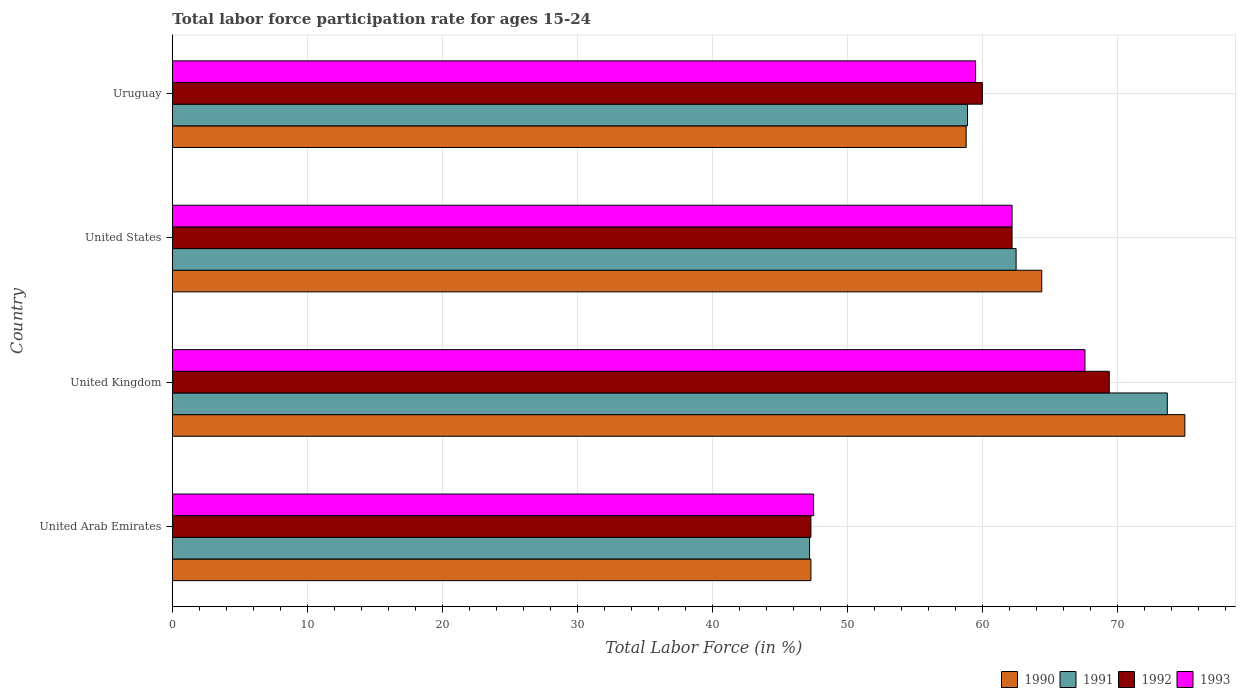How many different coloured bars are there?
Give a very brief answer. 4. Are the number of bars per tick equal to the number of legend labels?
Provide a succinct answer. Yes. Are the number of bars on each tick of the Y-axis equal?
Your answer should be very brief. Yes. How many bars are there on the 3rd tick from the bottom?
Your answer should be compact. 4. What is the label of the 1st group of bars from the top?
Offer a terse response. Uruguay. What is the labor force participation rate in 1991 in United States?
Keep it short and to the point. 62.5. Across all countries, what is the minimum labor force participation rate in 1992?
Provide a succinct answer. 47.3. In which country was the labor force participation rate in 1992 maximum?
Offer a terse response. United Kingdom. In which country was the labor force participation rate in 1992 minimum?
Offer a very short reply. United Arab Emirates. What is the total labor force participation rate in 1990 in the graph?
Your answer should be very brief. 245.5. What is the difference between the labor force participation rate in 1990 in United Arab Emirates and that in Uruguay?
Keep it short and to the point. -11.5. What is the difference between the labor force participation rate in 1990 in Uruguay and the labor force participation rate in 1991 in United Arab Emirates?
Give a very brief answer. 11.6. What is the average labor force participation rate in 1990 per country?
Provide a short and direct response. 61.37. What is the difference between the labor force participation rate in 1992 and labor force participation rate in 1991 in United States?
Your answer should be very brief. -0.3. In how many countries, is the labor force participation rate in 1992 greater than 40 %?
Offer a terse response. 4. What is the ratio of the labor force participation rate in 1990 in United Kingdom to that in Uruguay?
Make the answer very short. 1.28. Is the labor force participation rate in 1991 in United States less than that in Uruguay?
Keep it short and to the point. No. Is the difference between the labor force participation rate in 1992 in United States and Uruguay greater than the difference between the labor force participation rate in 1991 in United States and Uruguay?
Your answer should be very brief. No. What is the difference between the highest and the second highest labor force participation rate in 1992?
Make the answer very short. 7.2. What is the difference between the highest and the lowest labor force participation rate in 1993?
Keep it short and to the point. 20.1. What does the 1st bar from the top in United States represents?
Give a very brief answer. 1993. What does the 4th bar from the bottom in United Kingdom represents?
Your answer should be compact. 1993. How many bars are there?
Keep it short and to the point. 16. What is the difference between two consecutive major ticks on the X-axis?
Ensure brevity in your answer.  10. Are the values on the major ticks of X-axis written in scientific E-notation?
Give a very brief answer. No. How are the legend labels stacked?
Your answer should be compact. Horizontal. What is the title of the graph?
Make the answer very short. Total labor force participation rate for ages 15-24. What is the Total Labor Force (in %) of 1990 in United Arab Emirates?
Provide a short and direct response. 47.3. What is the Total Labor Force (in %) of 1991 in United Arab Emirates?
Your answer should be compact. 47.2. What is the Total Labor Force (in %) of 1992 in United Arab Emirates?
Your answer should be very brief. 47.3. What is the Total Labor Force (in %) of 1993 in United Arab Emirates?
Your response must be concise. 47.5. What is the Total Labor Force (in %) in 1991 in United Kingdom?
Offer a very short reply. 73.7. What is the Total Labor Force (in %) in 1992 in United Kingdom?
Your answer should be very brief. 69.4. What is the Total Labor Force (in %) in 1993 in United Kingdom?
Your answer should be very brief. 67.6. What is the Total Labor Force (in %) of 1990 in United States?
Offer a very short reply. 64.4. What is the Total Labor Force (in %) in 1991 in United States?
Your answer should be very brief. 62.5. What is the Total Labor Force (in %) in 1992 in United States?
Your response must be concise. 62.2. What is the Total Labor Force (in %) in 1993 in United States?
Your answer should be compact. 62.2. What is the Total Labor Force (in %) in 1990 in Uruguay?
Provide a succinct answer. 58.8. What is the Total Labor Force (in %) of 1991 in Uruguay?
Your answer should be very brief. 58.9. What is the Total Labor Force (in %) in 1993 in Uruguay?
Provide a succinct answer. 59.5. Across all countries, what is the maximum Total Labor Force (in %) of 1990?
Keep it short and to the point. 75. Across all countries, what is the maximum Total Labor Force (in %) of 1991?
Make the answer very short. 73.7. Across all countries, what is the maximum Total Labor Force (in %) of 1992?
Offer a very short reply. 69.4. Across all countries, what is the maximum Total Labor Force (in %) of 1993?
Provide a succinct answer. 67.6. Across all countries, what is the minimum Total Labor Force (in %) in 1990?
Offer a very short reply. 47.3. Across all countries, what is the minimum Total Labor Force (in %) of 1991?
Your response must be concise. 47.2. Across all countries, what is the minimum Total Labor Force (in %) of 1992?
Provide a short and direct response. 47.3. Across all countries, what is the minimum Total Labor Force (in %) of 1993?
Provide a short and direct response. 47.5. What is the total Total Labor Force (in %) in 1990 in the graph?
Keep it short and to the point. 245.5. What is the total Total Labor Force (in %) of 1991 in the graph?
Your answer should be compact. 242.3. What is the total Total Labor Force (in %) of 1992 in the graph?
Provide a short and direct response. 238.9. What is the total Total Labor Force (in %) in 1993 in the graph?
Make the answer very short. 236.8. What is the difference between the Total Labor Force (in %) of 1990 in United Arab Emirates and that in United Kingdom?
Your response must be concise. -27.7. What is the difference between the Total Labor Force (in %) of 1991 in United Arab Emirates and that in United Kingdom?
Make the answer very short. -26.5. What is the difference between the Total Labor Force (in %) of 1992 in United Arab Emirates and that in United Kingdom?
Your answer should be very brief. -22.1. What is the difference between the Total Labor Force (in %) in 1993 in United Arab Emirates and that in United Kingdom?
Offer a terse response. -20.1. What is the difference between the Total Labor Force (in %) in 1990 in United Arab Emirates and that in United States?
Give a very brief answer. -17.1. What is the difference between the Total Labor Force (in %) in 1991 in United Arab Emirates and that in United States?
Your response must be concise. -15.3. What is the difference between the Total Labor Force (in %) in 1992 in United Arab Emirates and that in United States?
Offer a terse response. -14.9. What is the difference between the Total Labor Force (in %) of 1993 in United Arab Emirates and that in United States?
Your answer should be compact. -14.7. What is the difference between the Total Labor Force (in %) in 1990 in United Arab Emirates and that in Uruguay?
Your answer should be very brief. -11.5. What is the difference between the Total Labor Force (in %) in 1991 in United Arab Emirates and that in Uruguay?
Your answer should be compact. -11.7. What is the difference between the Total Labor Force (in %) of 1993 in United Arab Emirates and that in Uruguay?
Your answer should be compact. -12. What is the difference between the Total Labor Force (in %) of 1990 in United Kingdom and that in United States?
Your answer should be very brief. 10.6. What is the difference between the Total Labor Force (in %) of 1991 in United Kingdom and that in United States?
Keep it short and to the point. 11.2. What is the difference between the Total Labor Force (in %) of 1992 in United Kingdom and that in United States?
Your response must be concise. 7.2. What is the difference between the Total Labor Force (in %) in 1993 in United Kingdom and that in United States?
Your response must be concise. 5.4. What is the difference between the Total Labor Force (in %) in 1990 in United Kingdom and that in Uruguay?
Offer a very short reply. 16.2. What is the difference between the Total Labor Force (in %) of 1991 in United Kingdom and that in Uruguay?
Provide a succinct answer. 14.8. What is the difference between the Total Labor Force (in %) in 1990 in United States and that in Uruguay?
Your response must be concise. 5.6. What is the difference between the Total Labor Force (in %) in 1991 in United States and that in Uruguay?
Your response must be concise. 3.6. What is the difference between the Total Labor Force (in %) of 1990 in United Arab Emirates and the Total Labor Force (in %) of 1991 in United Kingdom?
Keep it short and to the point. -26.4. What is the difference between the Total Labor Force (in %) in 1990 in United Arab Emirates and the Total Labor Force (in %) in 1992 in United Kingdom?
Offer a terse response. -22.1. What is the difference between the Total Labor Force (in %) of 1990 in United Arab Emirates and the Total Labor Force (in %) of 1993 in United Kingdom?
Provide a short and direct response. -20.3. What is the difference between the Total Labor Force (in %) in 1991 in United Arab Emirates and the Total Labor Force (in %) in 1992 in United Kingdom?
Your response must be concise. -22.2. What is the difference between the Total Labor Force (in %) in 1991 in United Arab Emirates and the Total Labor Force (in %) in 1993 in United Kingdom?
Your response must be concise. -20.4. What is the difference between the Total Labor Force (in %) of 1992 in United Arab Emirates and the Total Labor Force (in %) of 1993 in United Kingdom?
Offer a very short reply. -20.3. What is the difference between the Total Labor Force (in %) in 1990 in United Arab Emirates and the Total Labor Force (in %) in 1991 in United States?
Provide a succinct answer. -15.2. What is the difference between the Total Labor Force (in %) in 1990 in United Arab Emirates and the Total Labor Force (in %) in 1992 in United States?
Provide a succinct answer. -14.9. What is the difference between the Total Labor Force (in %) of 1990 in United Arab Emirates and the Total Labor Force (in %) of 1993 in United States?
Ensure brevity in your answer.  -14.9. What is the difference between the Total Labor Force (in %) in 1991 in United Arab Emirates and the Total Labor Force (in %) in 1993 in United States?
Give a very brief answer. -15. What is the difference between the Total Labor Force (in %) of 1992 in United Arab Emirates and the Total Labor Force (in %) of 1993 in United States?
Offer a very short reply. -14.9. What is the difference between the Total Labor Force (in %) in 1990 in United Arab Emirates and the Total Labor Force (in %) in 1991 in Uruguay?
Your answer should be compact. -11.6. What is the difference between the Total Labor Force (in %) of 1990 in United Arab Emirates and the Total Labor Force (in %) of 1992 in Uruguay?
Provide a short and direct response. -12.7. What is the difference between the Total Labor Force (in %) in 1991 in United Arab Emirates and the Total Labor Force (in %) in 1992 in Uruguay?
Ensure brevity in your answer.  -12.8. What is the difference between the Total Labor Force (in %) in 1991 in United Kingdom and the Total Labor Force (in %) in 1992 in United States?
Give a very brief answer. 11.5. What is the difference between the Total Labor Force (in %) in 1990 in United Kingdom and the Total Labor Force (in %) in 1993 in Uruguay?
Provide a short and direct response. 15.5. What is the difference between the Total Labor Force (in %) of 1992 in United Kingdom and the Total Labor Force (in %) of 1993 in Uruguay?
Provide a short and direct response. 9.9. What is the difference between the Total Labor Force (in %) of 1990 in United States and the Total Labor Force (in %) of 1991 in Uruguay?
Provide a short and direct response. 5.5. What is the difference between the Total Labor Force (in %) of 1990 in United States and the Total Labor Force (in %) of 1992 in Uruguay?
Your response must be concise. 4.4. What is the difference between the Total Labor Force (in %) of 1990 in United States and the Total Labor Force (in %) of 1993 in Uruguay?
Keep it short and to the point. 4.9. What is the difference between the Total Labor Force (in %) in 1991 in United States and the Total Labor Force (in %) in 1992 in Uruguay?
Make the answer very short. 2.5. What is the difference between the Total Labor Force (in %) of 1992 in United States and the Total Labor Force (in %) of 1993 in Uruguay?
Keep it short and to the point. 2.7. What is the average Total Labor Force (in %) of 1990 per country?
Offer a terse response. 61.38. What is the average Total Labor Force (in %) of 1991 per country?
Keep it short and to the point. 60.58. What is the average Total Labor Force (in %) in 1992 per country?
Keep it short and to the point. 59.73. What is the average Total Labor Force (in %) of 1993 per country?
Give a very brief answer. 59.2. What is the difference between the Total Labor Force (in %) of 1990 and Total Labor Force (in %) of 1992 in United Arab Emirates?
Give a very brief answer. 0. What is the difference between the Total Labor Force (in %) in 1991 and Total Labor Force (in %) in 1992 in United Arab Emirates?
Your answer should be very brief. -0.1. What is the difference between the Total Labor Force (in %) in 1991 and Total Labor Force (in %) in 1993 in United Arab Emirates?
Provide a succinct answer. -0.3. What is the difference between the Total Labor Force (in %) in 1992 and Total Labor Force (in %) in 1993 in United Arab Emirates?
Provide a succinct answer. -0.2. What is the difference between the Total Labor Force (in %) in 1990 and Total Labor Force (in %) in 1991 in United Kingdom?
Keep it short and to the point. 1.3. What is the difference between the Total Labor Force (in %) of 1990 and Total Labor Force (in %) of 1992 in United Kingdom?
Your answer should be very brief. 5.6. What is the difference between the Total Labor Force (in %) in 1990 and Total Labor Force (in %) in 1993 in United Kingdom?
Provide a succinct answer. 7.4. What is the difference between the Total Labor Force (in %) of 1990 and Total Labor Force (in %) of 1991 in United States?
Give a very brief answer. 1.9. What is the difference between the Total Labor Force (in %) of 1991 and Total Labor Force (in %) of 1992 in United States?
Ensure brevity in your answer.  0.3. What is the difference between the Total Labor Force (in %) in 1990 and Total Labor Force (in %) in 1993 in Uruguay?
Your response must be concise. -0.7. What is the ratio of the Total Labor Force (in %) in 1990 in United Arab Emirates to that in United Kingdom?
Provide a succinct answer. 0.63. What is the ratio of the Total Labor Force (in %) in 1991 in United Arab Emirates to that in United Kingdom?
Ensure brevity in your answer.  0.64. What is the ratio of the Total Labor Force (in %) in 1992 in United Arab Emirates to that in United Kingdom?
Ensure brevity in your answer.  0.68. What is the ratio of the Total Labor Force (in %) of 1993 in United Arab Emirates to that in United Kingdom?
Provide a short and direct response. 0.7. What is the ratio of the Total Labor Force (in %) of 1990 in United Arab Emirates to that in United States?
Give a very brief answer. 0.73. What is the ratio of the Total Labor Force (in %) in 1991 in United Arab Emirates to that in United States?
Your answer should be compact. 0.76. What is the ratio of the Total Labor Force (in %) in 1992 in United Arab Emirates to that in United States?
Offer a very short reply. 0.76. What is the ratio of the Total Labor Force (in %) of 1993 in United Arab Emirates to that in United States?
Provide a short and direct response. 0.76. What is the ratio of the Total Labor Force (in %) in 1990 in United Arab Emirates to that in Uruguay?
Offer a terse response. 0.8. What is the ratio of the Total Labor Force (in %) of 1991 in United Arab Emirates to that in Uruguay?
Your answer should be compact. 0.8. What is the ratio of the Total Labor Force (in %) of 1992 in United Arab Emirates to that in Uruguay?
Your answer should be compact. 0.79. What is the ratio of the Total Labor Force (in %) of 1993 in United Arab Emirates to that in Uruguay?
Provide a short and direct response. 0.8. What is the ratio of the Total Labor Force (in %) in 1990 in United Kingdom to that in United States?
Make the answer very short. 1.16. What is the ratio of the Total Labor Force (in %) of 1991 in United Kingdom to that in United States?
Your answer should be very brief. 1.18. What is the ratio of the Total Labor Force (in %) of 1992 in United Kingdom to that in United States?
Your answer should be compact. 1.12. What is the ratio of the Total Labor Force (in %) in 1993 in United Kingdom to that in United States?
Ensure brevity in your answer.  1.09. What is the ratio of the Total Labor Force (in %) of 1990 in United Kingdom to that in Uruguay?
Provide a short and direct response. 1.28. What is the ratio of the Total Labor Force (in %) of 1991 in United Kingdom to that in Uruguay?
Make the answer very short. 1.25. What is the ratio of the Total Labor Force (in %) in 1992 in United Kingdom to that in Uruguay?
Your answer should be very brief. 1.16. What is the ratio of the Total Labor Force (in %) in 1993 in United Kingdom to that in Uruguay?
Keep it short and to the point. 1.14. What is the ratio of the Total Labor Force (in %) of 1990 in United States to that in Uruguay?
Ensure brevity in your answer.  1.1. What is the ratio of the Total Labor Force (in %) of 1991 in United States to that in Uruguay?
Your answer should be compact. 1.06. What is the ratio of the Total Labor Force (in %) of 1992 in United States to that in Uruguay?
Offer a very short reply. 1.04. What is the ratio of the Total Labor Force (in %) of 1993 in United States to that in Uruguay?
Make the answer very short. 1.05. What is the difference between the highest and the second highest Total Labor Force (in %) in 1990?
Keep it short and to the point. 10.6. What is the difference between the highest and the second highest Total Labor Force (in %) in 1993?
Your response must be concise. 5.4. What is the difference between the highest and the lowest Total Labor Force (in %) in 1990?
Your response must be concise. 27.7. What is the difference between the highest and the lowest Total Labor Force (in %) of 1992?
Make the answer very short. 22.1. What is the difference between the highest and the lowest Total Labor Force (in %) of 1993?
Provide a succinct answer. 20.1. 